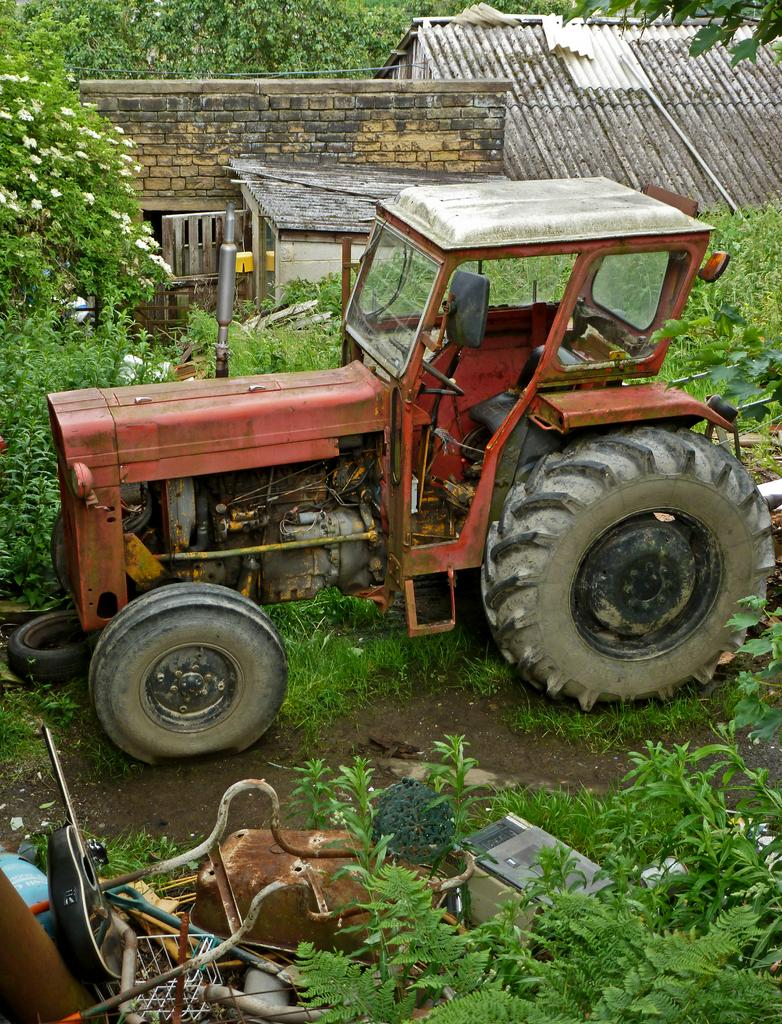What is the main subject on the ground in the image? There is a tractor on the ground in the image. What else can be seen in the image besides the tractor? There are objects, plants, grass, a stone wall, a house roof, and trees in the background visible in the image. Can you describe the vegetation in the image? There are plants and grass in the image. What type of structure is visible in the image? There is a stone wall and a house roof visible in the image. What can be seen in the background of the image? Trees are present in the background of the image. What type of bed can be seen in the image? There is no bed present in the image. What material is the marble made of in the image? There is no marble present in the image. 